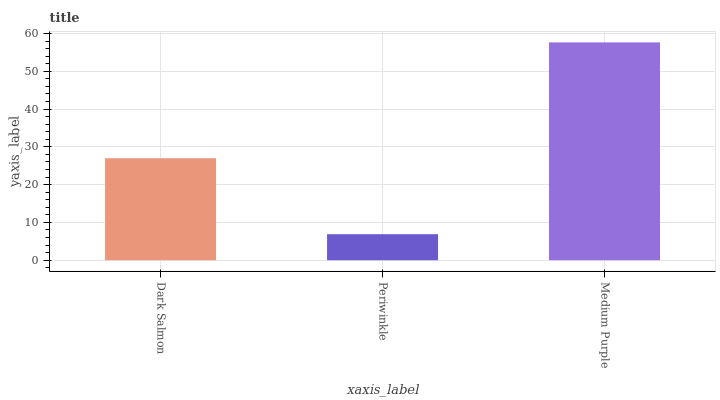Is Periwinkle the minimum?
Answer yes or no. Yes. Is Medium Purple the maximum?
Answer yes or no. Yes. Is Medium Purple the minimum?
Answer yes or no. No. Is Periwinkle the maximum?
Answer yes or no. No. Is Medium Purple greater than Periwinkle?
Answer yes or no. Yes. Is Periwinkle less than Medium Purple?
Answer yes or no. Yes. Is Periwinkle greater than Medium Purple?
Answer yes or no. No. Is Medium Purple less than Periwinkle?
Answer yes or no. No. Is Dark Salmon the high median?
Answer yes or no. Yes. Is Dark Salmon the low median?
Answer yes or no. Yes. Is Periwinkle the high median?
Answer yes or no. No. Is Periwinkle the low median?
Answer yes or no. No. 